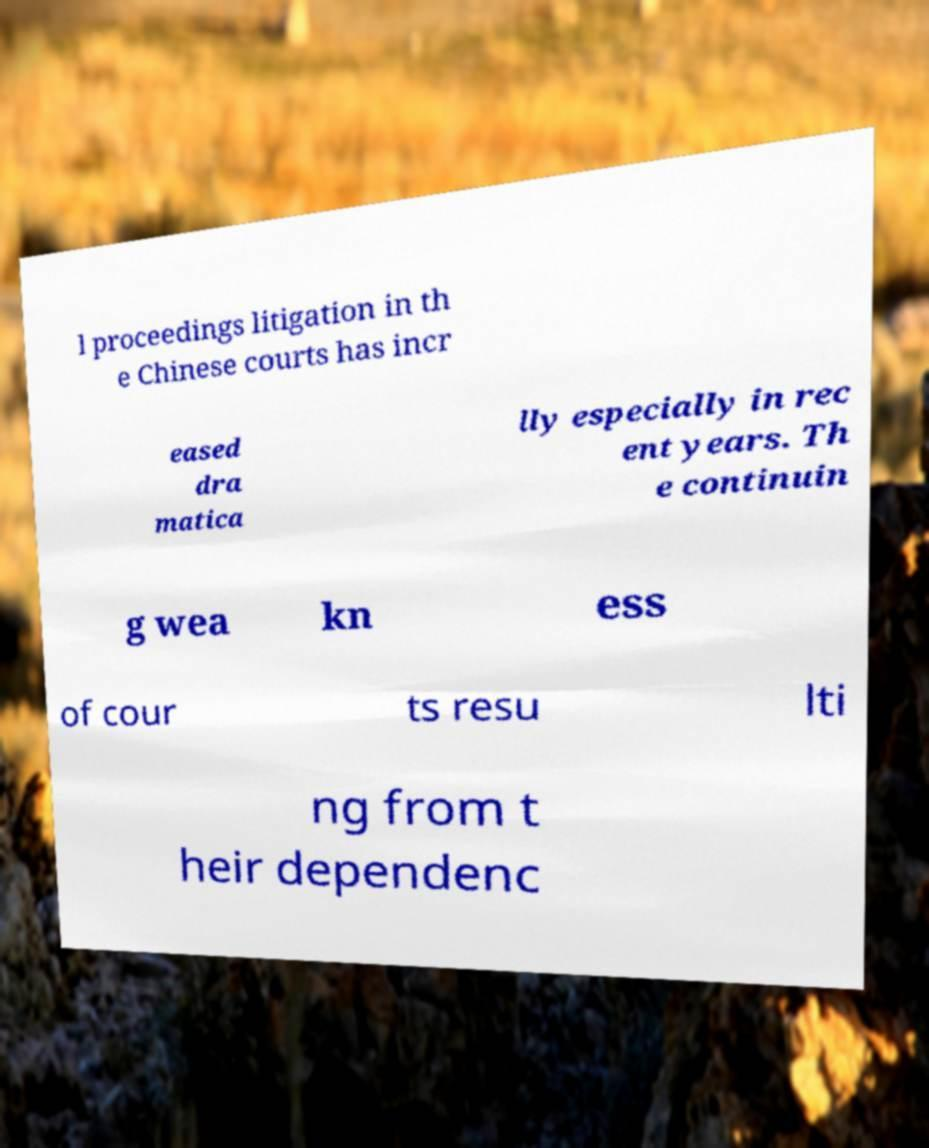Could you assist in decoding the text presented in this image and type it out clearly? l proceedings litigation in th e Chinese courts has incr eased dra matica lly especially in rec ent years. Th e continuin g wea kn ess of cour ts resu lti ng from t heir dependenc 